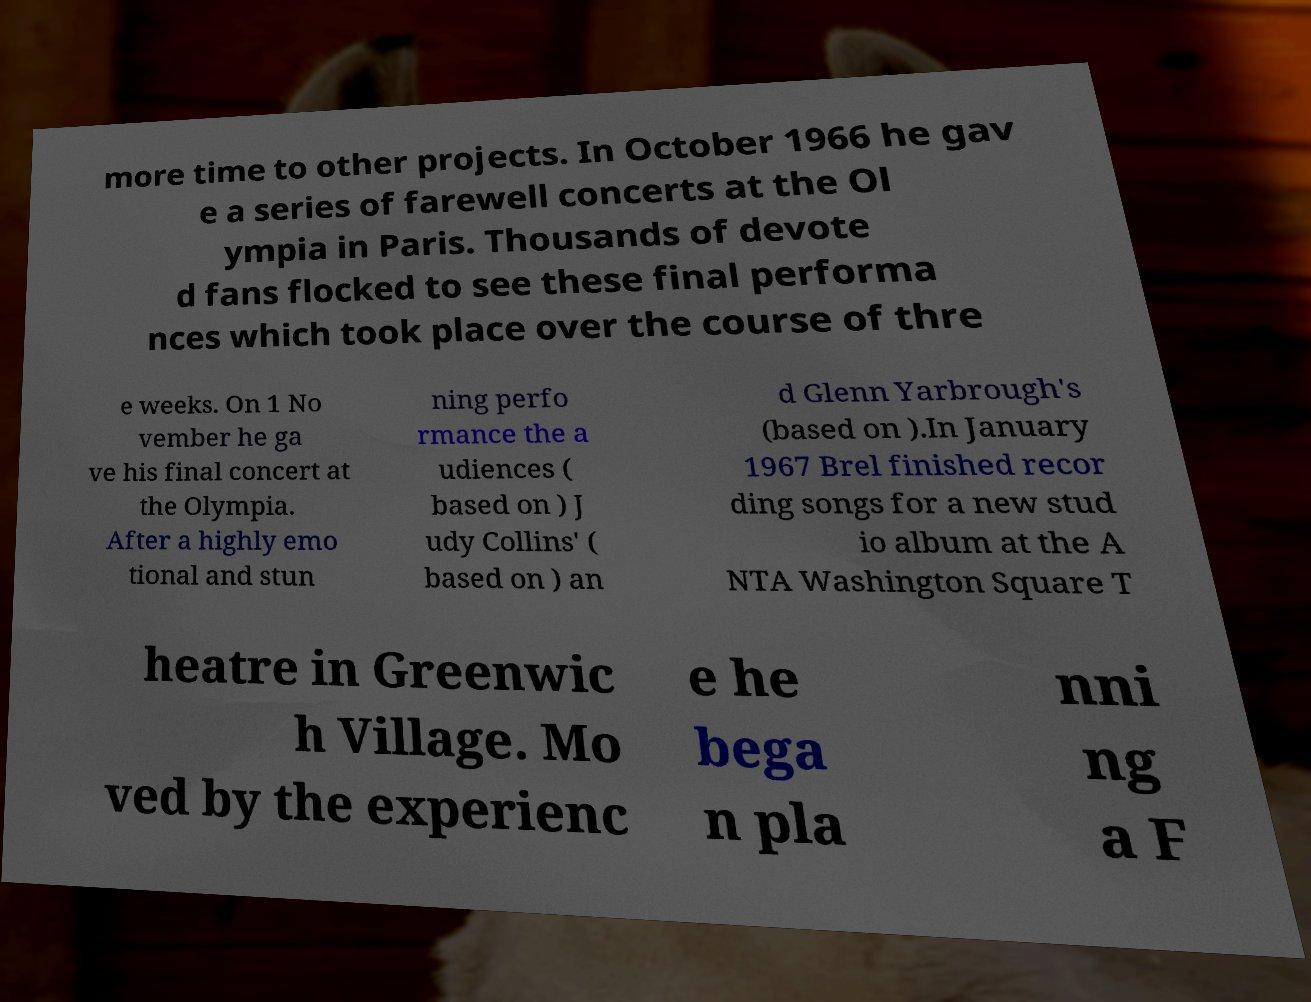I need the written content from this picture converted into text. Can you do that? more time to other projects. In October 1966 he gav e a series of farewell concerts at the Ol ympia in Paris. Thousands of devote d fans flocked to see these final performa nces which took place over the course of thre e weeks. On 1 No vember he ga ve his final concert at the Olympia. After a highly emo tional and stun ning perfo rmance the a udiences ( based on ) J udy Collins' ( based on ) an d Glenn Yarbrough's (based on ).In January 1967 Brel finished recor ding songs for a new stud io album at the A NTA Washington Square T heatre in Greenwic h Village. Mo ved by the experienc e he bega n pla nni ng a F 